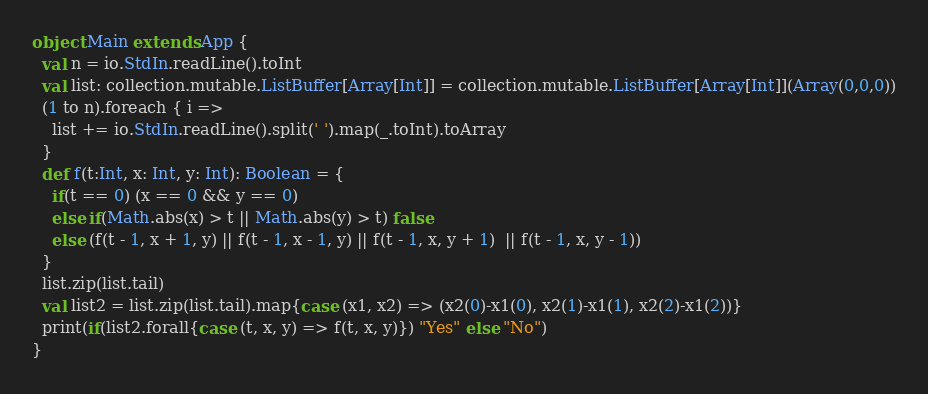Convert code to text. <code><loc_0><loc_0><loc_500><loc_500><_Scala_>object Main extends App {
  val n = io.StdIn.readLine().toInt
  val list: collection.mutable.ListBuffer[Array[Int]] = collection.mutable.ListBuffer[Array[Int]](Array(0,0,0))
  (1 to n).foreach { i =>
    list += io.StdIn.readLine().split(' ').map(_.toInt).toArray
  }  
  def f(t:Int, x: Int, y: Int): Boolean = {
    if(t == 0) (x == 0 && y == 0)
    else if(Math.abs(x) > t || Math.abs(y) > t) false
    else (f(t - 1, x + 1, y) || f(t - 1, x - 1, y) || f(t - 1, x, y + 1)  || f(t - 1, x, y - 1)) 
  }
  list.zip(list.tail)
  val list2 = list.zip(list.tail).map{case (x1, x2) => (x2(0)-x1(0), x2(1)-x1(1), x2(2)-x1(2))}
  print(if(list2.forall{case (t, x, y) => f(t, x, y)}) "Yes" else "No")
}

</code> 